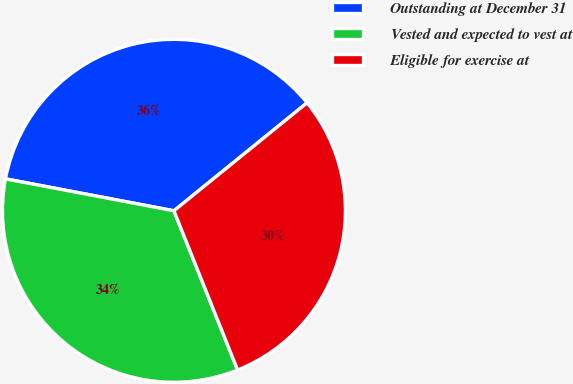<chart> <loc_0><loc_0><loc_500><loc_500><pie_chart><fcel>Outstanding at December 31<fcel>Vested and expected to vest at<fcel>Eligible for exercise at<nl><fcel>36.17%<fcel>34.04%<fcel>29.79%<nl></chart> 